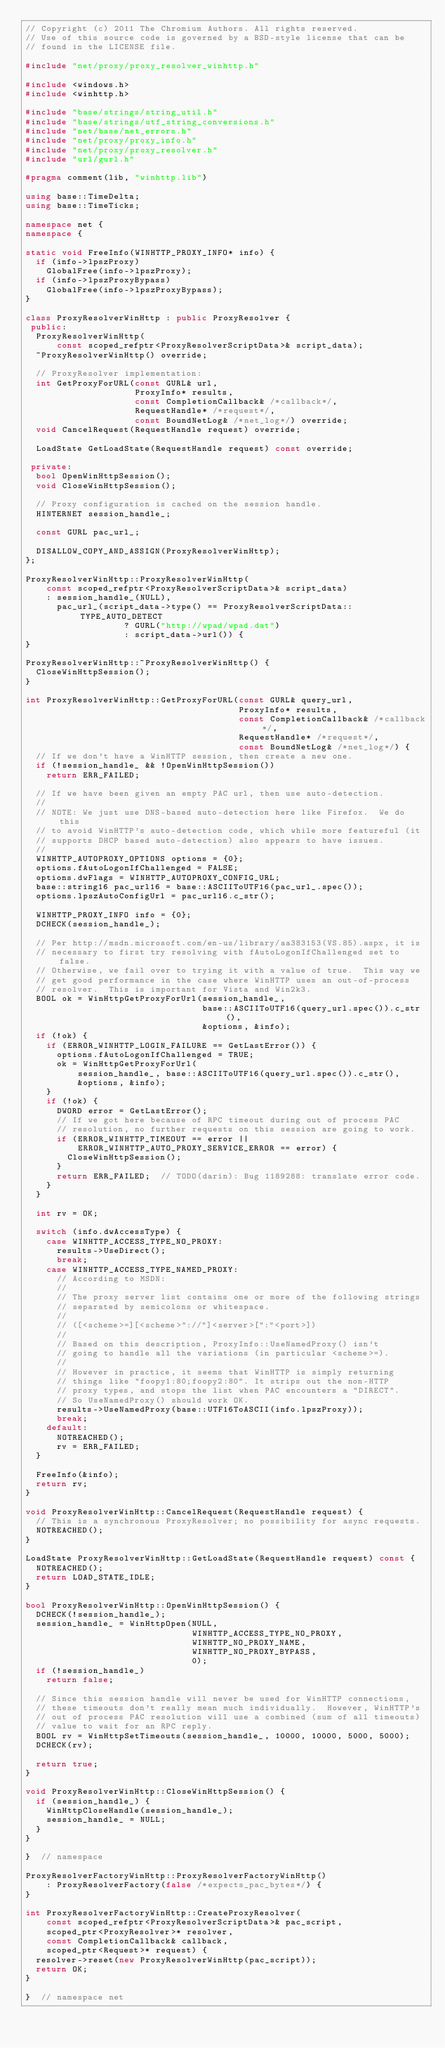<code> <loc_0><loc_0><loc_500><loc_500><_C++_>// Copyright (c) 2011 The Chromium Authors. All rights reserved.
// Use of this source code is governed by a BSD-style license that can be
// found in the LICENSE file.

#include "net/proxy/proxy_resolver_winhttp.h"

#include <windows.h>
#include <winhttp.h>

#include "base/strings/string_util.h"
#include "base/strings/utf_string_conversions.h"
#include "net/base/net_errors.h"
#include "net/proxy/proxy_info.h"
#include "net/proxy/proxy_resolver.h"
#include "url/gurl.h"

#pragma comment(lib, "winhttp.lib")

using base::TimeDelta;
using base::TimeTicks;

namespace net {
namespace {

static void FreeInfo(WINHTTP_PROXY_INFO* info) {
  if (info->lpszProxy)
    GlobalFree(info->lpszProxy);
  if (info->lpszProxyBypass)
    GlobalFree(info->lpszProxyBypass);
}

class ProxyResolverWinHttp : public ProxyResolver {
 public:
  ProxyResolverWinHttp(
      const scoped_refptr<ProxyResolverScriptData>& script_data);
  ~ProxyResolverWinHttp() override;

  // ProxyResolver implementation:
  int GetProxyForURL(const GURL& url,
                     ProxyInfo* results,
                     const CompletionCallback& /*callback*/,
                     RequestHandle* /*request*/,
                     const BoundNetLog& /*net_log*/) override;
  void CancelRequest(RequestHandle request) override;

  LoadState GetLoadState(RequestHandle request) const override;

 private:
  bool OpenWinHttpSession();
  void CloseWinHttpSession();

  // Proxy configuration is cached on the session handle.
  HINTERNET session_handle_;

  const GURL pac_url_;

  DISALLOW_COPY_AND_ASSIGN(ProxyResolverWinHttp);
};

ProxyResolverWinHttp::ProxyResolverWinHttp(
    const scoped_refptr<ProxyResolverScriptData>& script_data)
    : session_handle_(NULL),
      pac_url_(script_data->type() == ProxyResolverScriptData::TYPE_AUTO_DETECT
                   ? GURL("http://wpad/wpad.dat")
                   : script_data->url()) {
}

ProxyResolverWinHttp::~ProxyResolverWinHttp() {
  CloseWinHttpSession();
}

int ProxyResolverWinHttp::GetProxyForURL(const GURL& query_url,
                                         ProxyInfo* results,
                                         const CompletionCallback& /*callback*/,
                                         RequestHandle* /*request*/,
                                         const BoundNetLog& /*net_log*/) {
  // If we don't have a WinHTTP session, then create a new one.
  if (!session_handle_ && !OpenWinHttpSession())
    return ERR_FAILED;

  // If we have been given an empty PAC url, then use auto-detection.
  //
  // NOTE: We just use DNS-based auto-detection here like Firefox.  We do this
  // to avoid WinHTTP's auto-detection code, which while more featureful (it
  // supports DHCP based auto-detection) also appears to have issues.
  //
  WINHTTP_AUTOPROXY_OPTIONS options = {0};
  options.fAutoLogonIfChallenged = FALSE;
  options.dwFlags = WINHTTP_AUTOPROXY_CONFIG_URL;
  base::string16 pac_url16 = base::ASCIIToUTF16(pac_url_.spec());
  options.lpszAutoConfigUrl = pac_url16.c_str();

  WINHTTP_PROXY_INFO info = {0};
  DCHECK(session_handle_);

  // Per http://msdn.microsoft.com/en-us/library/aa383153(VS.85).aspx, it is
  // necessary to first try resolving with fAutoLogonIfChallenged set to false.
  // Otherwise, we fail over to trying it with a value of true.  This way we
  // get good performance in the case where WinHTTP uses an out-of-process
  // resolver.  This is important for Vista and Win2k3.
  BOOL ok = WinHttpGetProxyForUrl(session_handle_,
                                  base::ASCIIToUTF16(query_url.spec()).c_str(),
                                  &options, &info);
  if (!ok) {
    if (ERROR_WINHTTP_LOGIN_FAILURE == GetLastError()) {
      options.fAutoLogonIfChallenged = TRUE;
      ok = WinHttpGetProxyForUrl(
          session_handle_, base::ASCIIToUTF16(query_url.spec()).c_str(),
          &options, &info);
    }
    if (!ok) {
      DWORD error = GetLastError();
      // If we got here because of RPC timeout during out of process PAC
      // resolution, no further requests on this session are going to work.
      if (ERROR_WINHTTP_TIMEOUT == error ||
          ERROR_WINHTTP_AUTO_PROXY_SERVICE_ERROR == error) {
        CloseWinHttpSession();
      }
      return ERR_FAILED;  // TODO(darin): Bug 1189288: translate error code.
    }
  }

  int rv = OK;

  switch (info.dwAccessType) {
    case WINHTTP_ACCESS_TYPE_NO_PROXY:
      results->UseDirect();
      break;
    case WINHTTP_ACCESS_TYPE_NAMED_PROXY:
      // According to MSDN:
      //
      // The proxy server list contains one or more of the following strings
      // separated by semicolons or whitespace.
      //
      // ([<scheme>=][<scheme>"://"]<server>[":"<port>])
      //
      // Based on this description, ProxyInfo::UseNamedProxy() isn't
      // going to handle all the variations (in particular <scheme>=).
      //
      // However in practice, it seems that WinHTTP is simply returning
      // things like "foopy1:80;foopy2:80". It strips out the non-HTTP
      // proxy types, and stops the list when PAC encounters a "DIRECT".
      // So UseNamedProxy() should work OK.
      results->UseNamedProxy(base::UTF16ToASCII(info.lpszProxy));
      break;
    default:
      NOTREACHED();
      rv = ERR_FAILED;
  }

  FreeInfo(&info);
  return rv;
}

void ProxyResolverWinHttp::CancelRequest(RequestHandle request) {
  // This is a synchronous ProxyResolver; no possibility for async requests.
  NOTREACHED();
}

LoadState ProxyResolverWinHttp::GetLoadState(RequestHandle request) const {
  NOTREACHED();
  return LOAD_STATE_IDLE;
}

bool ProxyResolverWinHttp::OpenWinHttpSession() {
  DCHECK(!session_handle_);
  session_handle_ = WinHttpOpen(NULL,
                                WINHTTP_ACCESS_TYPE_NO_PROXY,
                                WINHTTP_NO_PROXY_NAME,
                                WINHTTP_NO_PROXY_BYPASS,
                                0);
  if (!session_handle_)
    return false;

  // Since this session handle will never be used for WinHTTP connections,
  // these timeouts don't really mean much individually.  However, WinHTTP's
  // out of process PAC resolution will use a combined (sum of all timeouts)
  // value to wait for an RPC reply.
  BOOL rv = WinHttpSetTimeouts(session_handle_, 10000, 10000, 5000, 5000);
  DCHECK(rv);

  return true;
}

void ProxyResolverWinHttp::CloseWinHttpSession() {
  if (session_handle_) {
    WinHttpCloseHandle(session_handle_);
    session_handle_ = NULL;
  }
}

}  // namespace

ProxyResolverFactoryWinHttp::ProxyResolverFactoryWinHttp()
    : ProxyResolverFactory(false /*expects_pac_bytes*/) {
}

int ProxyResolverFactoryWinHttp::CreateProxyResolver(
    const scoped_refptr<ProxyResolverScriptData>& pac_script,
    scoped_ptr<ProxyResolver>* resolver,
    const CompletionCallback& callback,
    scoped_ptr<Request>* request) {
  resolver->reset(new ProxyResolverWinHttp(pac_script));
  return OK;
}

}  // namespace net
</code> 